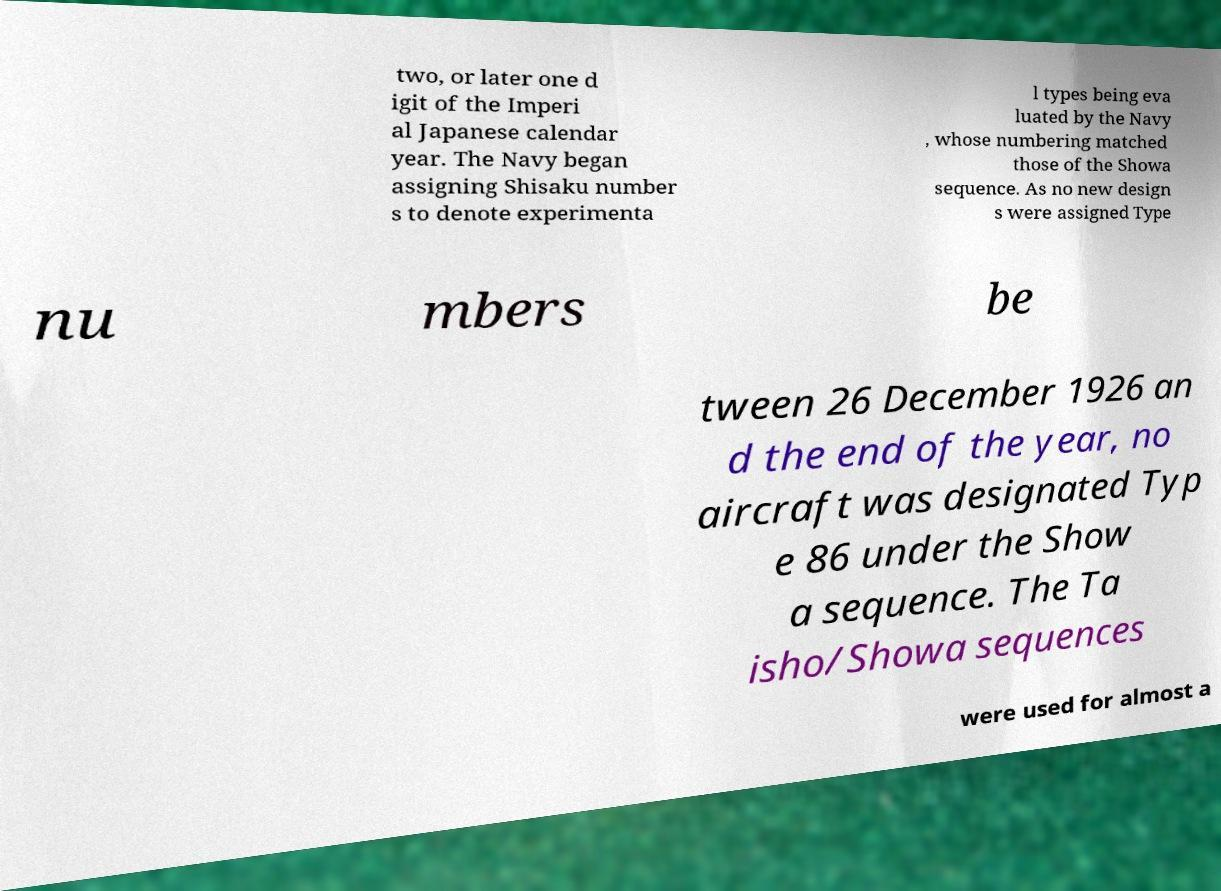For documentation purposes, I need the text within this image transcribed. Could you provide that? two, or later one d igit of the Imperi al Japanese calendar year. The Navy began assigning Shisaku number s to denote experimenta l types being eva luated by the Navy , whose numbering matched those of the Showa sequence. As no new design s were assigned Type nu mbers be tween 26 December 1926 an d the end of the year, no aircraft was designated Typ e 86 under the Show a sequence. The Ta isho/Showa sequences were used for almost a 